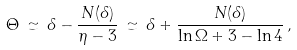<formula> <loc_0><loc_0><loc_500><loc_500>\Theta \, \simeq \, \delta - \frac { N ( \delta ) } { \eta - 3 } \, \simeq \, \delta + \frac { N ( \delta ) } { \ln \Omega + 3 - \ln 4 } \, ,</formula> 